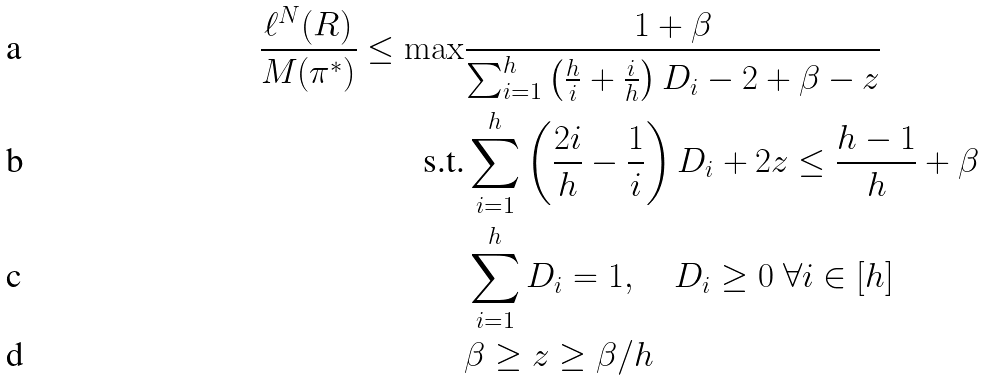<formula> <loc_0><loc_0><loc_500><loc_500>\frac { \ell ^ { N } ( R ) } { M ( \pi ^ { * } ) } \leq \max & \frac { 1 + \beta } { \sum _ { i = 1 } ^ { h } \left ( \frac { h } { i } + \frac { i } h \right ) D _ { i } - 2 + \beta - { z } } \\ \text {s.t.} & \sum _ { i = 1 } ^ { h } \left ( \frac { 2 i } h - \frac { 1 } i \right ) D _ { i } + 2 { z } \leq \frac { h - 1 } { h } + \beta \\ & \sum _ { i = 1 } ^ { h } D _ { i } = 1 , \quad D _ { i } \geq 0 \ \forall i \in [ h ] \\ & \beta \geq { z } \geq \beta / { h }</formula> 